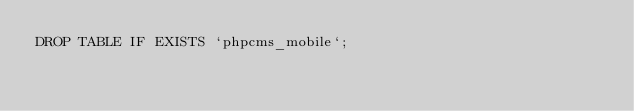Convert code to text. <code><loc_0><loc_0><loc_500><loc_500><_SQL_>DROP TABLE IF EXISTS `phpcms_mobile`;</code> 